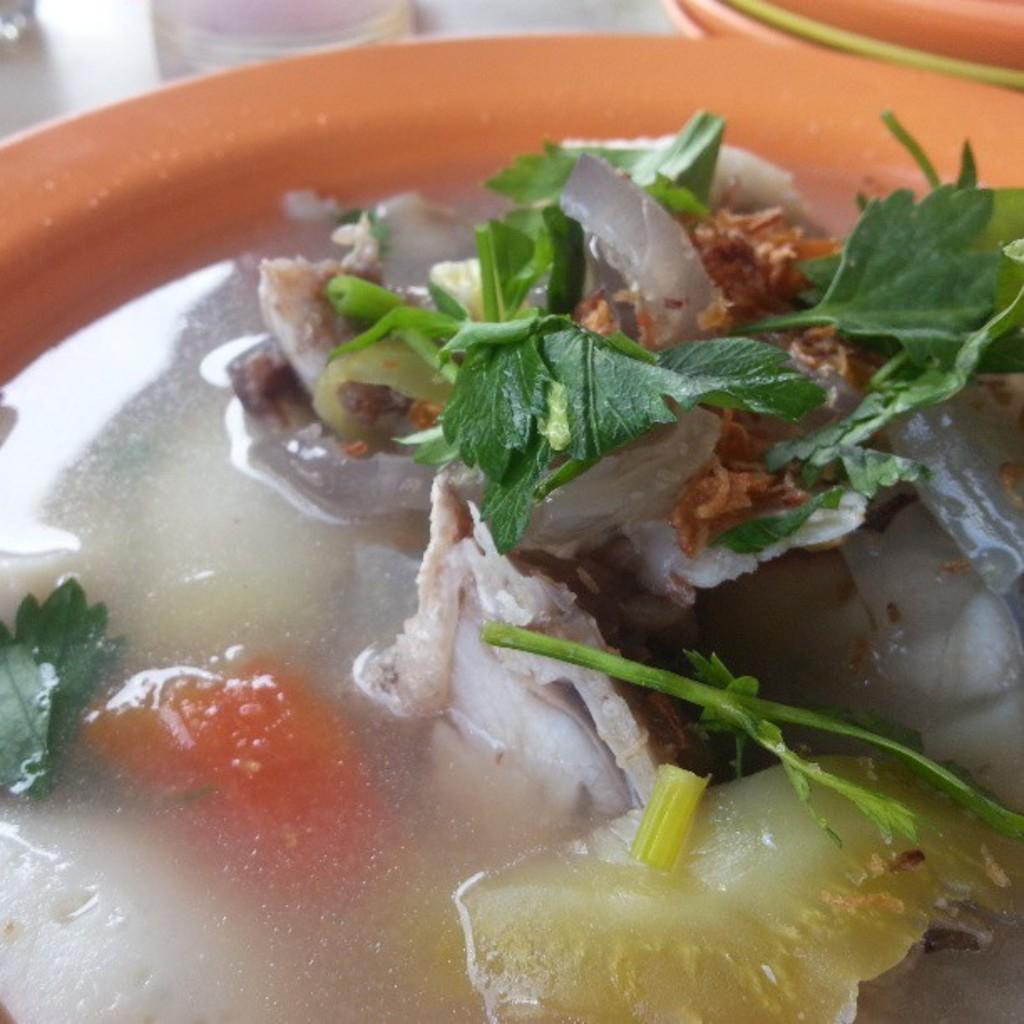How would you summarize this image in a sentence or two? In this picture we can see food in the plate. 